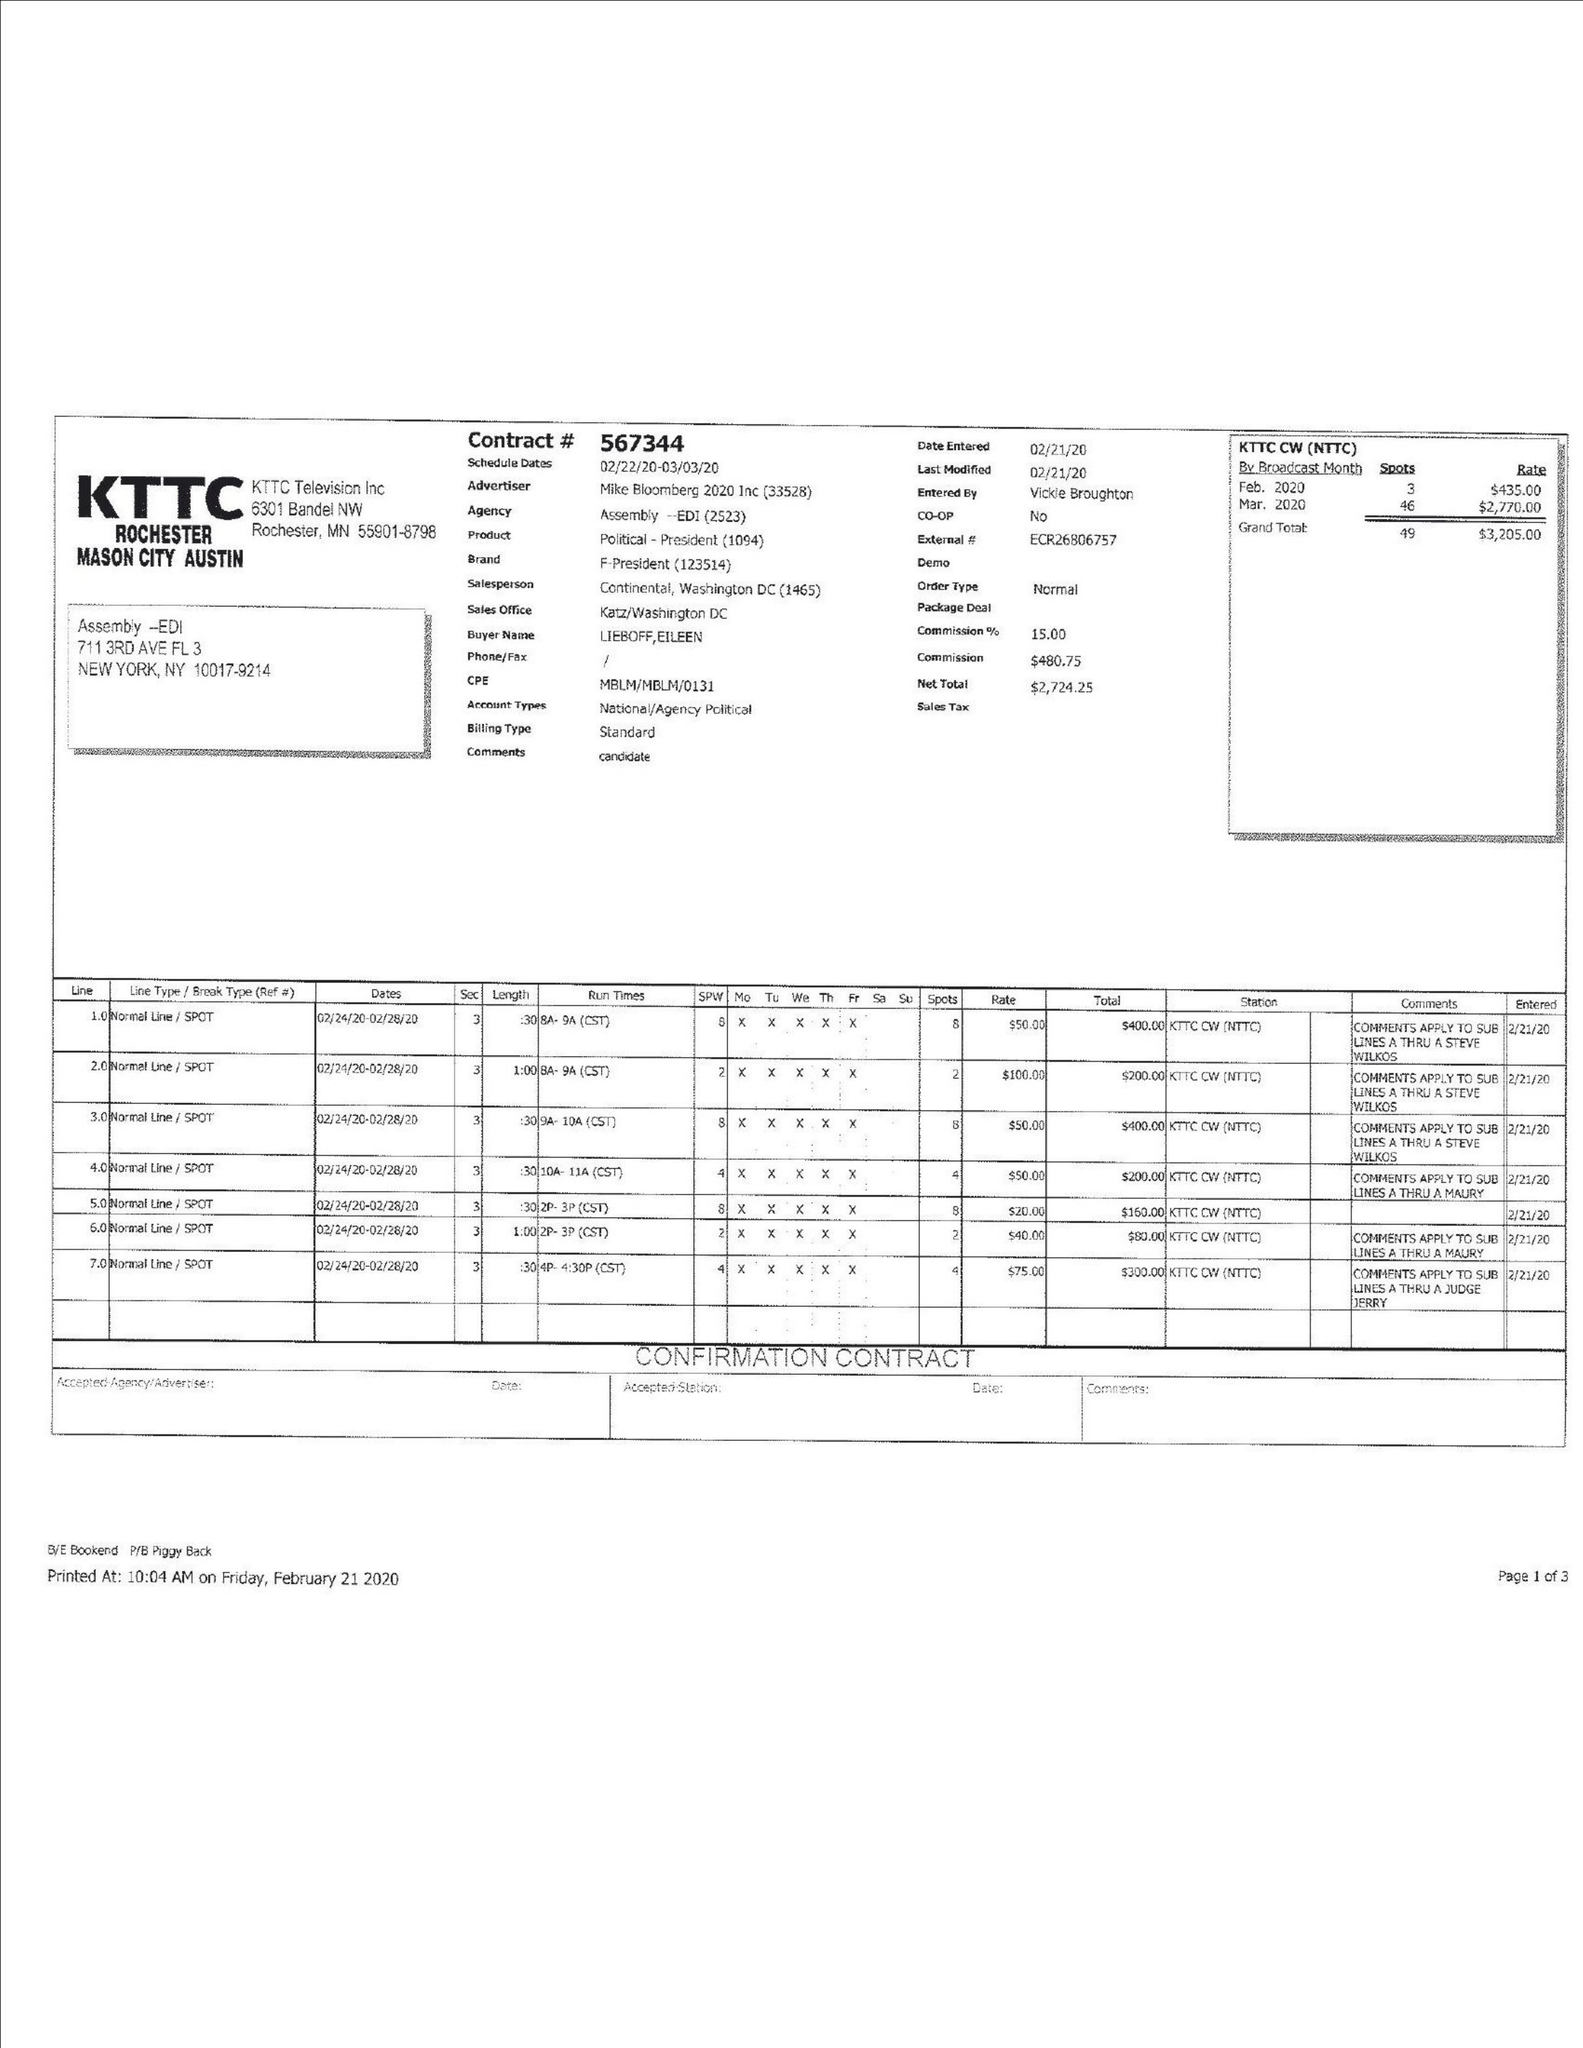What is the value for the gross_amount?
Answer the question using a single word or phrase. 3205.00 